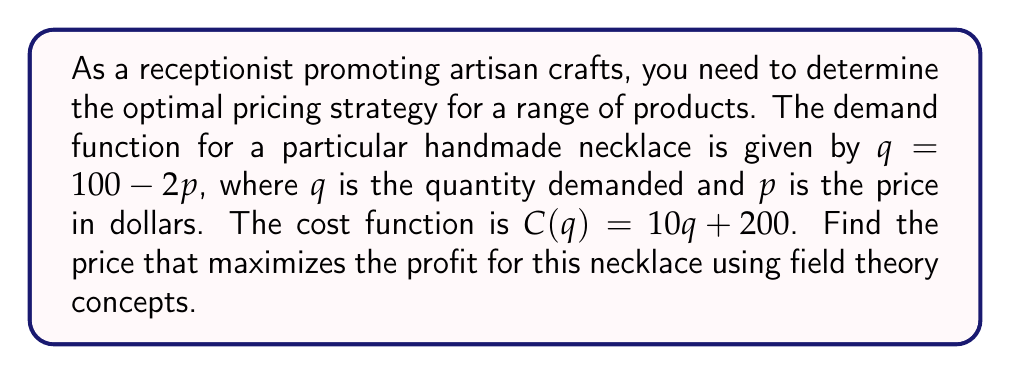Give your solution to this math problem. 1) First, we need to express the profit function in terms of price $p$:
   Profit = Revenue - Cost
   $\pi(p) = pq - C(q)$

2) Substitute the demand function $q = 100 - 2p$ into the profit function:
   $\pi(p) = p(100 - 2p) - [10(100 - 2p) + 200]$

3) Expand the equation:
   $\pi(p) = 100p - 2p^2 - 1000 + 20p - 200$
   $\pi(p) = -2p^2 + 120p - 1200$

4) To find the maximum profit, we need to find the critical point. Take the derivative of $\pi(p)$ with respect to $p$ and set it to zero:
   $$\frac{d\pi}{dp} = -4p + 120 = 0$$

5) Solve for $p$:
   $-4p = -120$
   $p = 30$

6) To confirm this is a maximum, check the second derivative:
   $$\frac{d^2\pi}{dp^2} = -4 < 0$$
   This confirms that $p = 30$ gives a maximum.

7) The optimal price is $30.
Answer: $30 